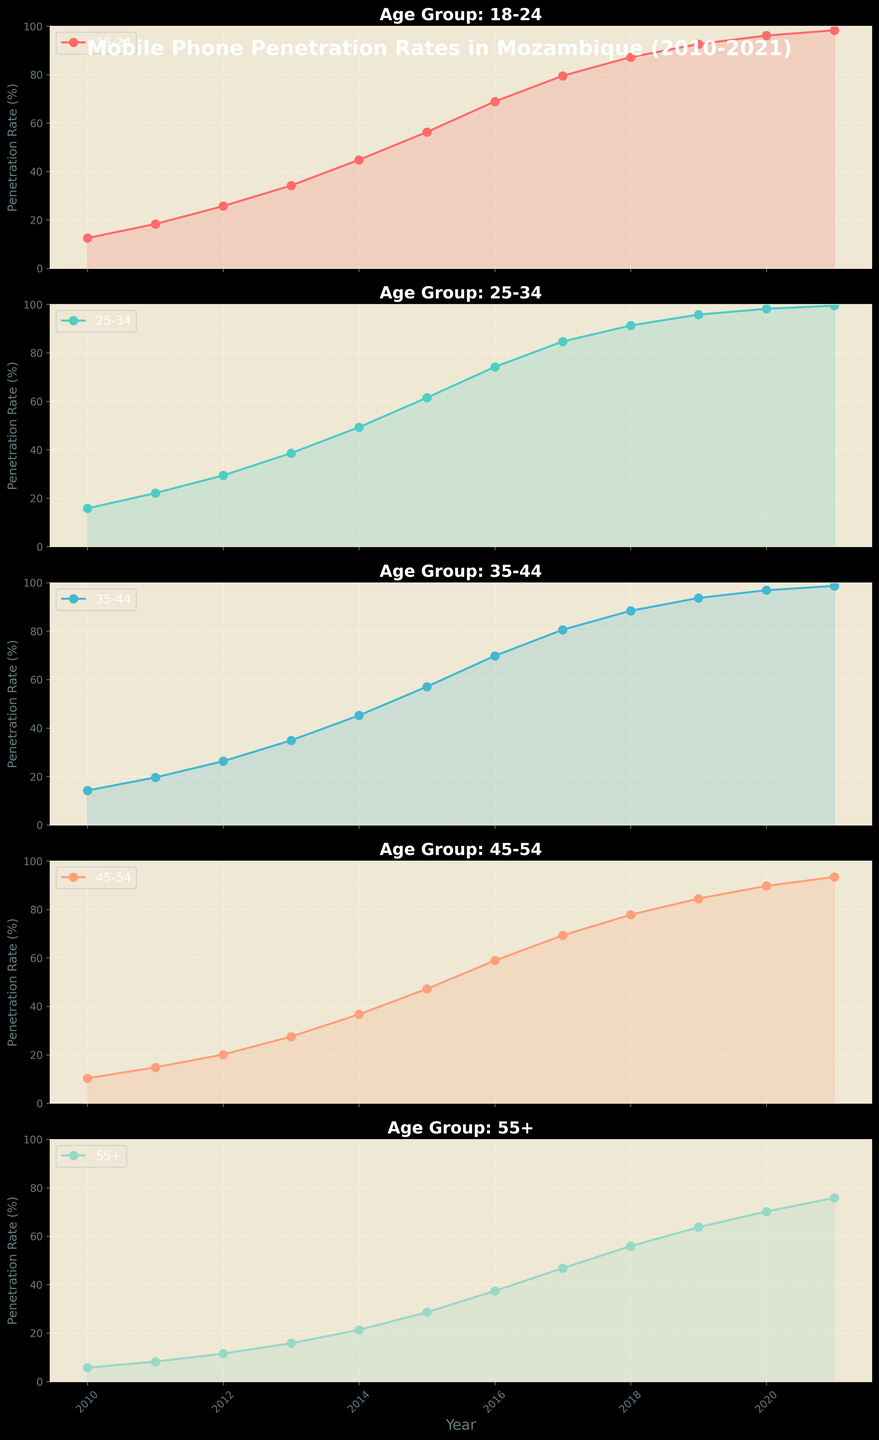What is the overall trend of mobile phone penetration rates in all age groups from 2010 to 2021? Overall, all age groups show an increasing trend in mobile phone penetration rates from 2010 to 2021. This can be observed as the lines for all age groups go upwards over the years in the figure.
Answer: Increasing Which age group had the highest mobile phone penetration rate in 2021? In 2021, the age group '25-34' had the highest mobile phone penetration rate as compared to other age groups. This is observed by the highest data point being reached by the '25-34' line in the subplot.
Answer: 25-34 Compare the mobile phone penetration rates between the age groups 18-24 and 55+ in 2015. Which age group had a higher rate and by how much? In 2015, the mobile phone penetration rate for '18-24' was 56.3% and for '55+' it was 28.6%. The difference is 56.3% - 28.6% = 27.7%, so the '18-24' age group had a higher penetration rate by 27.7%.
Answer: 18-24 by 27.7% Between which years did the age group 35-44 experience the largest increase in mobile phone penetration rates? The age group '35-44' experienced the largest increase between 2014 and 2015. The rate increased from 45.2% to 57.1%, which is a difference of 57.1% - 45.2% = 11.9%.
Answer: 2014-2015 What color represents the age group 45-54 in the figure? The age group '45-54' is represented by the color orange. This is observed by the color of the line and filled area in the subplot for the age group '45-54'.
Answer: Orange What is the average mobile phone penetration rate for the age group 18-24 from 2010 to 2021? The mobile phone penetration rates for '18-24' from 2010 to 2021 are: 12.5, 18.3, 25.7, 34.2, 44.8, 56.3, 68.9, 79.5, 87.2, 92.6, 96.1, 98.3. The sum is 715.5. Dividing by the number of years (12) gives an average of 715.5 / 12 = 59.63%.
Answer: 59.63% In which year did the age group 25-34 first surpass a penetration rate of 50%? The age group '25-34' first surpassed a penetration rate of 50% in 2014, where the penetration rate was 49.3%. In 2015, it reached 61.5%.
Answer: 2015 Which age group shows the most significant growth trend in mobile phone penetration rates between 2010 and 2021? The age group '55+' shows the most significant growth trend. Starting at 5.7% in 2010 and reaching 75.8% in 2021, it has the steepest upward slope among the age groups.
Answer: 55+ How does the penetration rate for the age group 45-54 in 2020 compare to that in 2010? In 2020, the penetration rate for the age group '45-54' was 89.7%, whereas in 2010 it was 10.3%. The difference is 89.7% - 10.3% = 79.4%.
Answer: Increased by 79.4% 